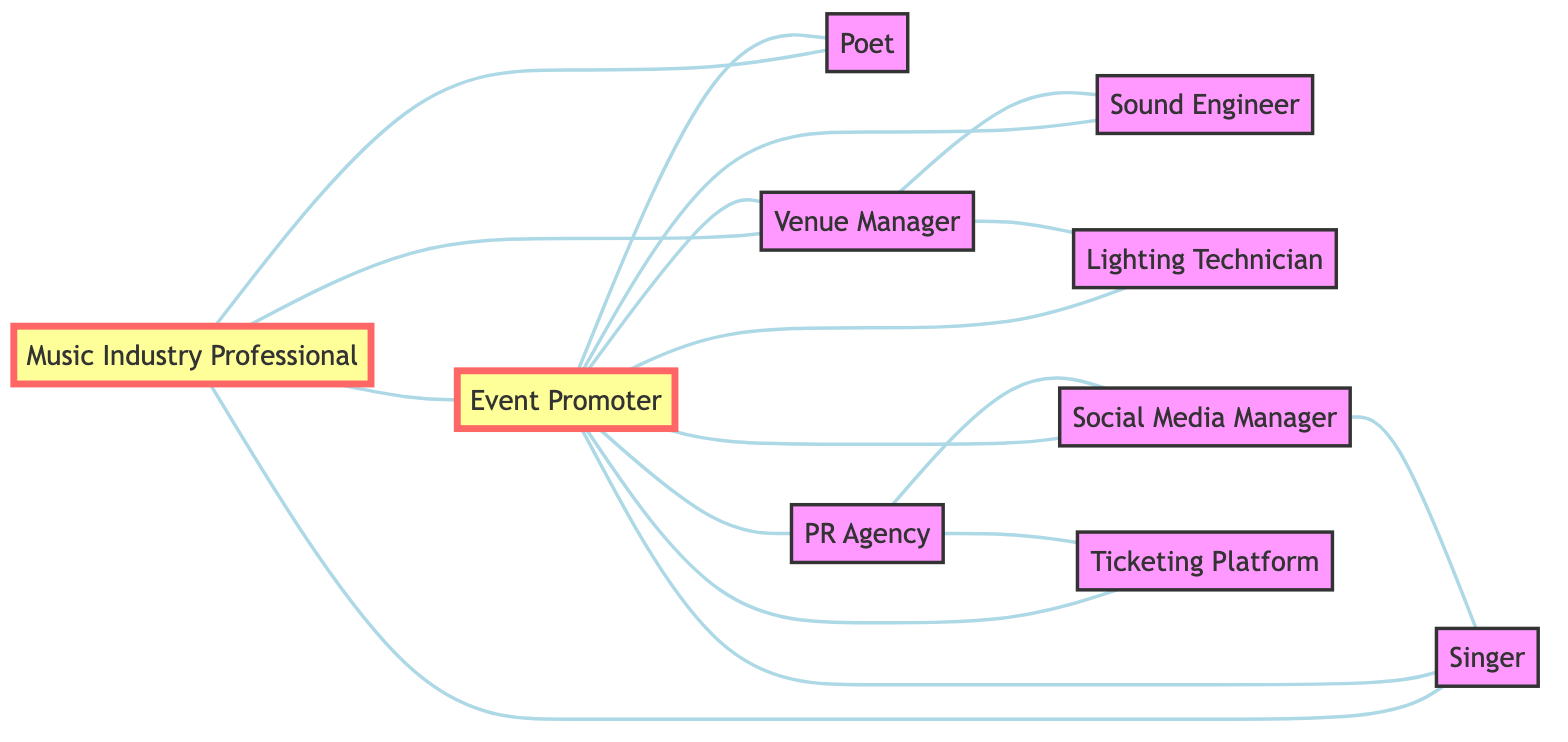What are the total number of nodes in the diagram? The diagram contains 10 nodes, which are Music Industry Professional, Singer, Poet, Event Promoter, Venue Manager, Sound Engineer, Lighting Technician, PR Agency, Social Media Manager, and Ticketing Platform.
Answer: 10 How many edges connect the Event Promoter to other professionals? The Event Promoter is connected to seven other nodes: Singer, Poet, Venue Manager, Sound Engineer, Lighting Technician, PR Agency, and Social Media Manager.
Answer: 7 Which professional is connected to the most nodes? The Event Promoter is connected to seven nodes (Singer, Poet, Venue Manager, Sound Engineer, Lighting Technician, PR Agency, Social Media Manager, and Ticketing Platform), making it the professional with the most connections.
Answer: Event Promoter Is there a direct link between the Venue Manager and the Poet? There is no direct edge connecting the Venue Manager to the Poet, as they are not directly linked in the diagram.
Answer: No What profession has a direct relationship with the Social Media Manager? The Social Media Manager has a direct relationship with the PR Agency and the Singer, as evident from the edges connecting them to the Social Media Manager in the diagram.
Answer: PR Agency, Singer How many types of professionals are connected through the Event Promoter? The Event Promoter connects to various professionals: Singer, Poet, Venue Manager, Sound Engineer, Lighting Technician, PR Agency, Social Media Manager, and Ticketing Platform, totaling eight types.
Answer: 8 What is the relationship between the PR Agency and the Ticketing Platform? The PR Agency is connected to the Ticketing Platform through a direct edge, indicating a collaborative relationship in the context of event organization and promotion.
Answer: Direct connection Is there a link from the Music Industry Professional to the Lighting Technician? There is no direct edge connecting the Music Industry Professional to the Lighting Technician in the diagram, which indicates they do not have a direct relationship.
Answer: No 